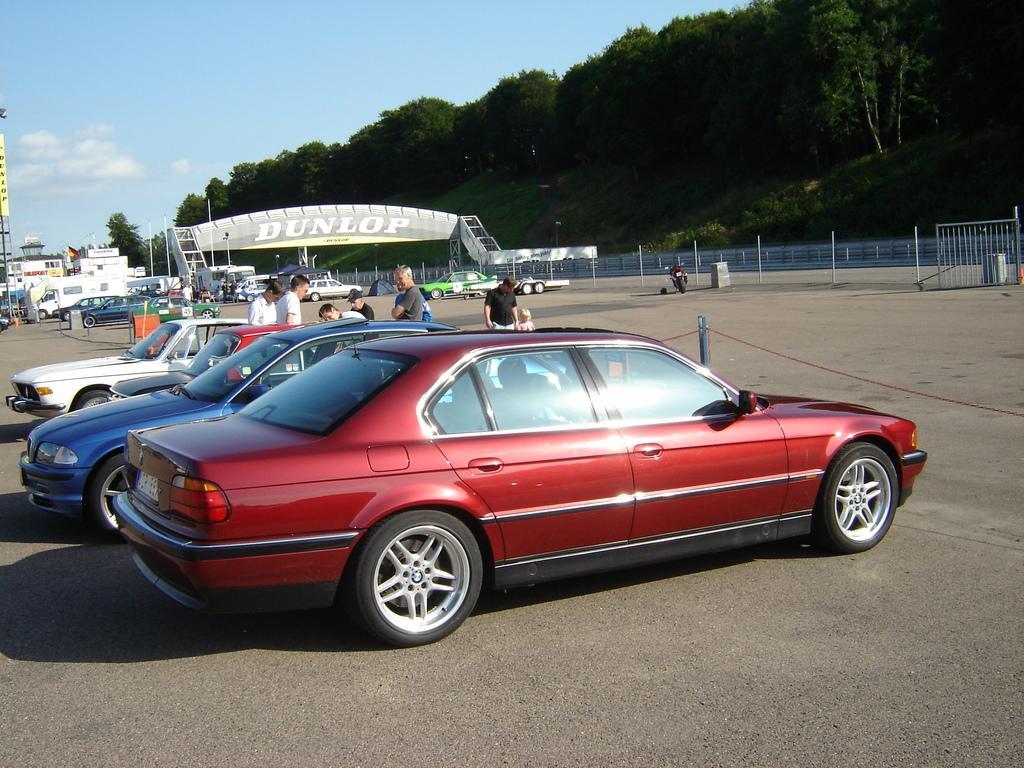Could you give a brief overview of what you see in this image? In this image we can see cars. There are people standing. In the background of the image there are trees, sky. At the bottom of the image there is road. There is a banner with some text. 